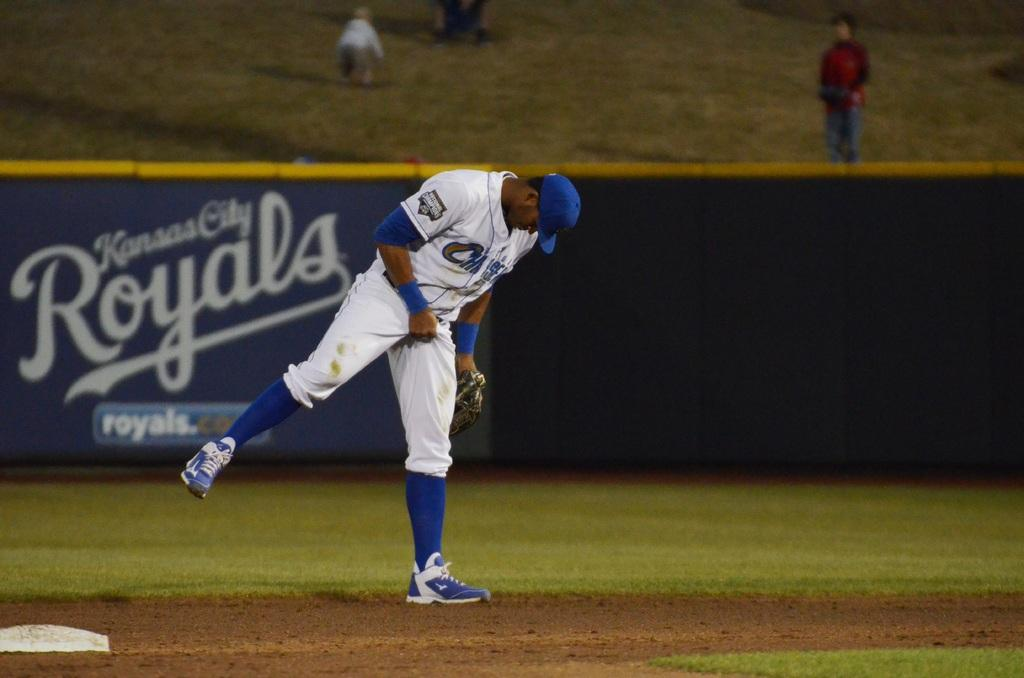Provide a one-sentence caption for the provided image. A Kansas City Royals player is shown on the baseball field grabbing his junk. 